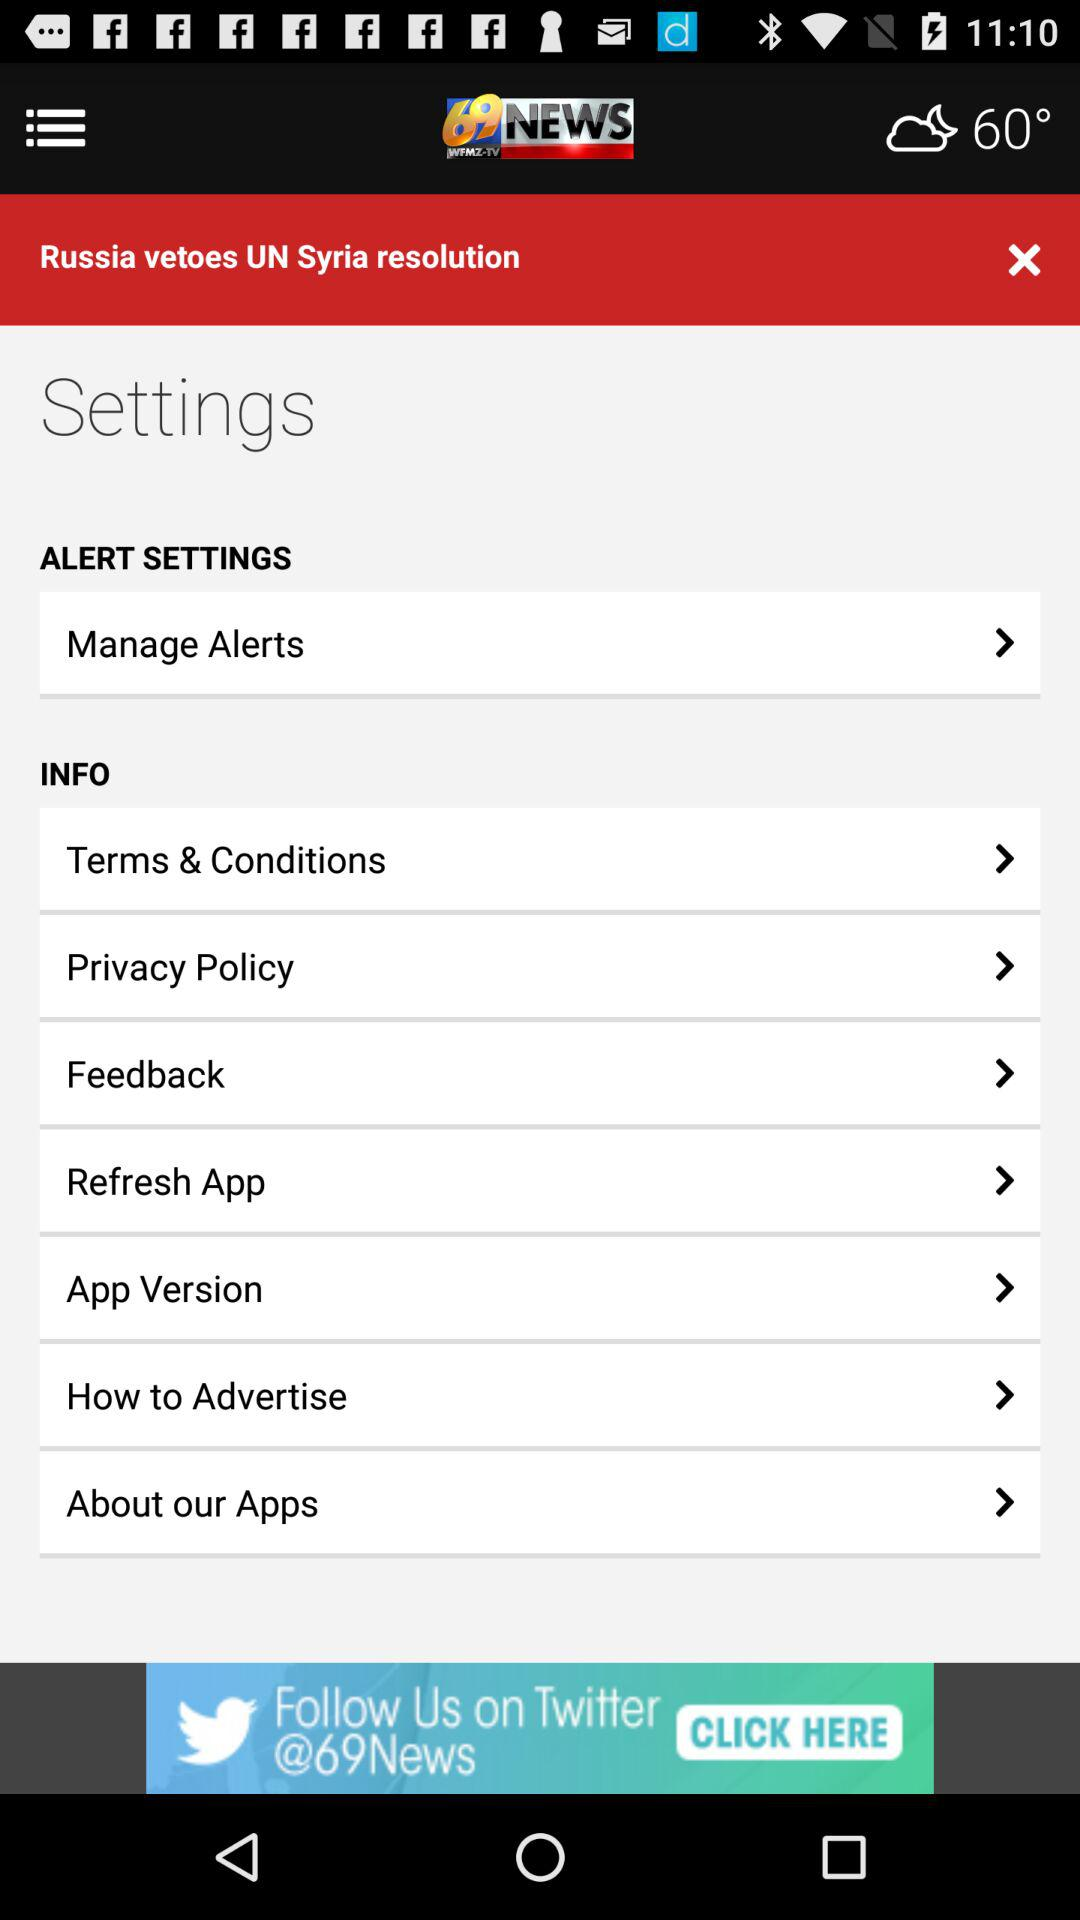What is the temperature? The temperature is 60°. 